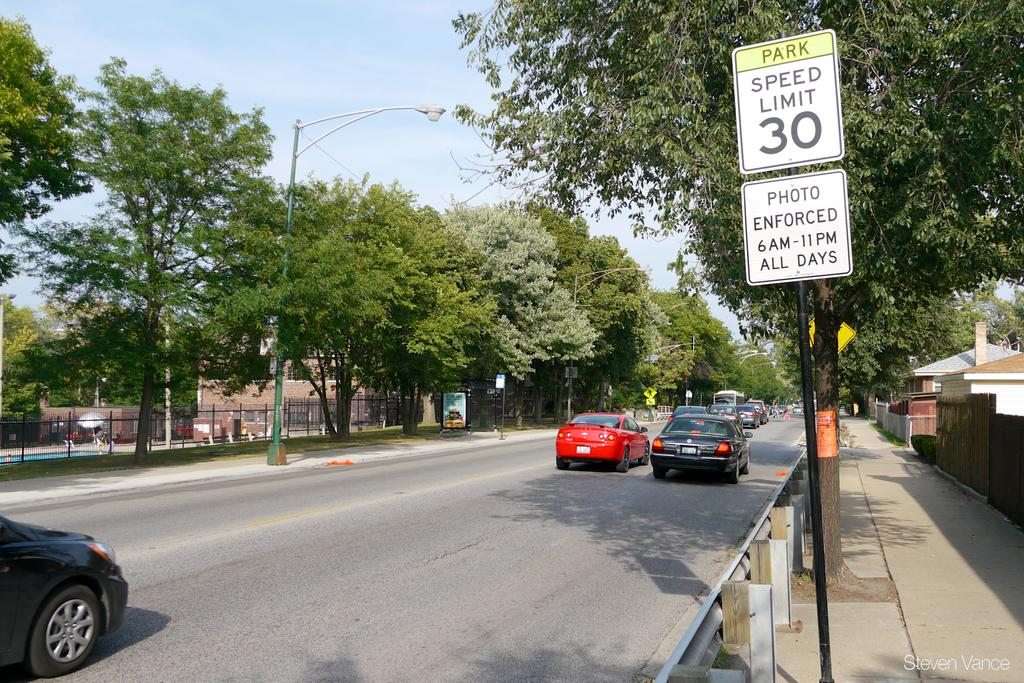<image>
Give a short and clear explanation of the subsequent image. A street with a 30mph speed limit has a few cars going down it. 